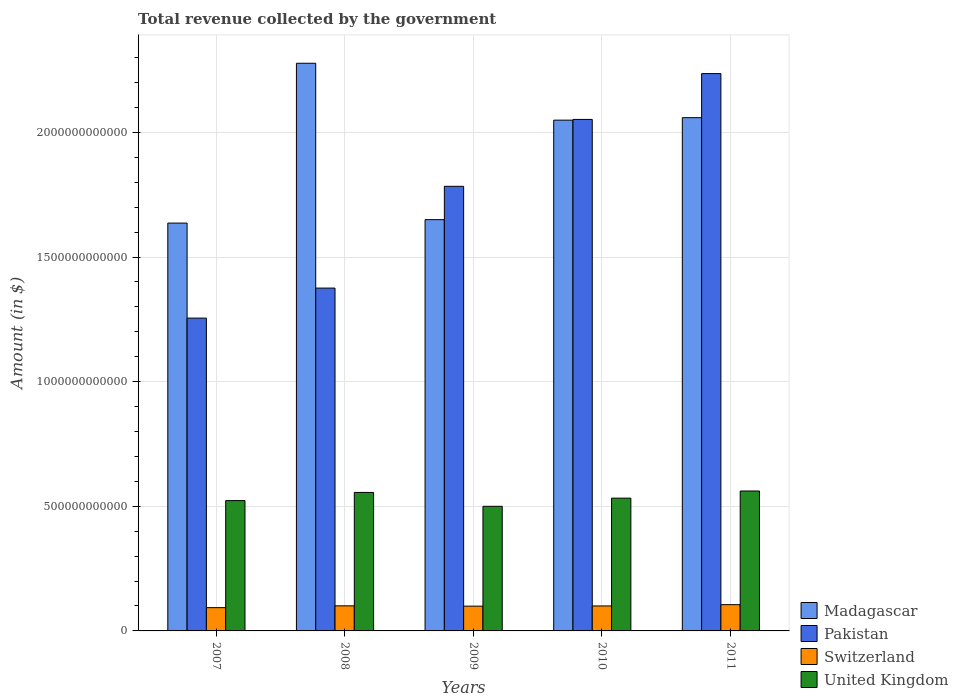How many different coloured bars are there?
Your answer should be compact. 4. Are the number of bars on each tick of the X-axis equal?
Your answer should be very brief. Yes. How many bars are there on the 5th tick from the left?
Provide a succinct answer. 4. What is the total revenue collected by the government in Switzerland in 2009?
Your answer should be very brief. 9.94e+1. Across all years, what is the maximum total revenue collected by the government in United Kingdom?
Your answer should be very brief. 5.61e+11. Across all years, what is the minimum total revenue collected by the government in Madagascar?
Keep it short and to the point. 1.64e+12. In which year was the total revenue collected by the government in Switzerland minimum?
Offer a terse response. 2007. What is the total total revenue collected by the government in Switzerland in the graph?
Keep it short and to the point. 4.99e+11. What is the difference between the total revenue collected by the government in Pakistan in 2007 and that in 2009?
Make the answer very short. -5.29e+11. What is the difference between the total revenue collected by the government in Madagascar in 2010 and the total revenue collected by the government in Pakistan in 2009?
Make the answer very short. 2.65e+11. What is the average total revenue collected by the government in Pakistan per year?
Your answer should be very brief. 1.74e+12. In the year 2007, what is the difference between the total revenue collected by the government in United Kingdom and total revenue collected by the government in Switzerland?
Provide a short and direct response. 4.29e+11. In how many years, is the total revenue collected by the government in Pakistan greater than 700000000000 $?
Your answer should be very brief. 5. What is the ratio of the total revenue collected by the government in Switzerland in 2007 to that in 2008?
Offer a very short reply. 0.93. Is the total revenue collected by the government in Madagascar in 2008 less than that in 2011?
Provide a short and direct response. No. Is the difference between the total revenue collected by the government in United Kingdom in 2007 and 2008 greater than the difference between the total revenue collected by the government in Switzerland in 2007 and 2008?
Offer a very short reply. No. What is the difference between the highest and the second highest total revenue collected by the government in Switzerland?
Provide a short and direct response. 4.70e+09. What is the difference between the highest and the lowest total revenue collected by the government in Pakistan?
Provide a succinct answer. 9.81e+11. Is the sum of the total revenue collected by the government in Pakistan in 2008 and 2009 greater than the maximum total revenue collected by the government in Madagascar across all years?
Offer a terse response. Yes. Is it the case that in every year, the sum of the total revenue collected by the government in Pakistan and total revenue collected by the government in Switzerland is greater than the sum of total revenue collected by the government in United Kingdom and total revenue collected by the government in Madagascar?
Your answer should be very brief. Yes. What does the 3rd bar from the left in 2011 represents?
Offer a very short reply. Switzerland. What does the 2nd bar from the right in 2011 represents?
Your response must be concise. Switzerland. How many bars are there?
Give a very brief answer. 20. Are all the bars in the graph horizontal?
Make the answer very short. No. What is the difference between two consecutive major ticks on the Y-axis?
Keep it short and to the point. 5.00e+11. Does the graph contain any zero values?
Offer a very short reply. No. Does the graph contain grids?
Your answer should be compact. Yes. Where does the legend appear in the graph?
Provide a succinct answer. Bottom right. How many legend labels are there?
Keep it short and to the point. 4. What is the title of the graph?
Your response must be concise. Total revenue collected by the government. What is the label or title of the X-axis?
Provide a succinct answer. Years. What is the label or title of the Y-axis?
Your answer should be very brief. Amount (in $). What is the Amount (in $) in Madagascar in 2007?
Your answer should be very brief. 1.64e+12. What is the Amount (in $) in Pakistan in 2007?
Your answer should be very brief. 1.25e+12. What is the Amount (in $) in Switzerland in 2007?
Your answer should be very brief. 9.34e+1. What is the Amount (in $) of United Kingdom in 2007?
Offer a very short reply. 5.23e+11. What is the Amount (in $) of Madagascar in 2008?
Ensure brevity in your answer.  2.28e+12. What is the Amount (in $) of Pakistan in 2008?
Your response must be concise. 1.38e+12. What is the Amount (in $) of Switzerland in 2008?
Offer a very short reply. 1.01e+11. What is the Amount (in $) in United Kingdom in 2008?
Your answer should be compact. 5.56e+11. What is the Amount (in $) of Madagascar in 2009?
Your answer should be very brief. 1.65e+12. What is the Amount (in $) of Pakistan in 2009?
Offer a very short reply. 1.78e+12. What is the Amount (in $) in Switzerland in 2009?
Offer a very short reply. 9.94e+1. What is the Amount (in $) of United Kingdom in 2009?
Offer a very short reply. 5.00e+11. What is the Amount (in $) of Madagascar in 2010?
Provide a short and direct response. 2.05e+12. What is the Amount (in $) of Pakistan in 2010?
Ensure brevity in your answer.  2.05e+12. What is the Amount (in $) in Switzerland in 2010?
Your answer should be very brief. 1.00e+11. What is the Amount (in $) in United Kingdom in 2010?
Your answer should be compact. 5.33e+11. What is the Amount (in $) in Madagascar in 2011?
Offer a very short reply. 2.06e+12. What is the Amount (in $) of Pakistan in 2011?
Make the answer very short. 2.24e+12. What is the Amount (in $) of Switzerland in 2011?
Give a very brief answer. 1.05e+11. What is the Amount (in $) of United Kingdom in 2011?
Provide a succinct answer. 5.61e+11. Across all years, what is the maximum Amount (in $) in Madagascar?
Offer a terse response. 2.28e+12. Across all years, what is the maximum Amount (in $) in Pakistan?
Provide a succinct answer. 2.24e+12. Across all years, what is the maximum Amount (in $) of Switzerland?
Offer a terse response. 1.05e+11. Across all years, what is the maximum Amount (in $) in United Kingdom?
Offer a very short reply. 5.61e+11. Across all years, what is the minimum Amount (in $) in Madagascar?
Provide a short and direct response. 1.64e+12. Across all years, what is the minimum Amount (in $) in Pakistan?
Provide a short and direct response. 1.25e+12. Across all years, what is the minimum Amount (in $) of Switzerland?
Your answer should be compact. 9.34e+1. Across all years, what is the minimum Amount (in $) in United Kingdom?
Your response must be concise. 5.00e+11. What is the total Amount (in $) of Madagascar in the graph?
Ensure brevity in your answer.  9.67e+12. What is the total Amount (in $) of Pakistan in the graph?
Ensure brevity in your answer.  8.70e+12. What is the total Amount (in $) in Switzerland in the graph?
Offer a terse response. 4.99e+11. What is the total Amount (in $) in United Kingdom in the graph?
Provide a succinct answer. 2.67e+12. What is the difference between the Amount (in $) of Madagascar in 2007 and that in 2008?
Your answer should be very brief. -6.41e+11. What is the difference between the Amount (in $) of Pakistan in 2007 and that in 2008?
Offer a terse response. -1.20e+11. What is the difference between the Amount (in $) of Switzerland in 2007 and that in 2008?
Give a very brief answer. -7.27e+09. What is the difference between the Amount (in $) in United Kingdom in 2007 and that in 2008?
Make the answer very short. -3.27e+1. What is the difference between the Amount (in $) of Madagascar in 2007 and that in 2009?
Your answer should be compact. -1.38e+1. What is the difference between the Amount (in $) in Pakistan in 2007 and that in 2009?
Provide a short and direct response. -5.29e+11. What is the difference between the Amount (in $) of Switzerland in 2007 and that in 2009?
Ensure brevity in your answer.  -6.03e+09. What is the difference between the Amount (in $) in United Kingdom in 2007 and that in 2009?
Keep it short and to the point. 2.29e+1. What is the difference between the Amount (in $) in Madagascar in 2007 and that in 2010?
Give a very brief answer. -4.13e+11. What is the difference between the Amount (in $) in Pakistan in 2007 and that in 2010?
Your answer should be very brief. -7.97e+11. What is the difference between the Amount (in $) of Switzerland in 2007 and that in 2010?
Provide a short and direct response. -6.83e+09. What is the difference between the Amount (in $) in United Kingdom in 2007 and that in 2010?
Offer a terse response. -9.82e+09. What is the difference between the Amount (in $) in Madagascar in 2007 and that in 2011?
Ensure brevity in your answer.  -4.23e+11. What is the difference between the Amount (in $) of Pakistan in 2007 and that in 2011?
Provide a succinct answer. -9.81e+11. What is the difference between the Amount (in $) of Switzerland in 2007 and that in 2011?
Your response must be concise. -1.20e+1. What is the difference between the Amount (in $) in United Kingdom in 2007 and that in 2011?
Your answer should be very brief. -3.85e+1. What is the difference between the Amount (in $) of Madagascar in 2008 and that in 2009?
Offer a very short reply. 6.27e+11. What is the difference between the Amount (in $) of Pakistan in 2008 and that in 2009?
Make the answer very short. -4.08e+11. What is the difference between the Amount (in $) in Switzerland in 2008 and that in 2009?
Provide a short and direct response. 1.24e+09. What is the difference between the Amount (in $) of United Kingdom in 2008 and that in 2009?
Your response must be concise. 5.56e+1. What is the difference between the Amount (in $) in Madagascar in 2008 and that in 2010?
Give a very brief answer. 2.28e+11. What is the difference between the Amount (in $) in Pakistan in 2008 and that in 2010?
Ensure brevity in your answer.  -6.77e+11. What is the difference between the Amount (in $) in Switzerland in 2008 and that in 2010?
Give a very brief answer. 4.42e+08. What is the difference between the Amount (in $) in United Kingdom in 2008 and that in 2010?
Your answer should be compact. 2.29e+1. What is the difference between the Amount (in $) in Madagascar in 2008 and that in 2011?
Offer a terse response. 2.18e+11. What is the difference between the Amount (in $) in Pakistan in 2008 and that in 2011?
Provide a short and direct response. -8.61e+11. What is the difference between the Amount (in $) of Switzerland in 2008 and that in 2011?
Your answer should be compact. -4.70e+09. What is the difference between the Amount (in $) in United Kingdom in 2008 and that in 2011?
Offer a very short reply. -5.77e+09. What is the difference between the Amount (in $) in Madagascar in 2009 and that in 2010?
Your answer should be very brief. -3.99e+11. What is the difference between the Amount (in $) in Pakistan in 2009 and that in 2010?
Offer a very short reply. -2.68e+11. What is the difference between the Amount (in $) of Switzerland in 2009 and that in 2010?
Ensure brevity in your answer.  -7.94e+08. What is the difference between the Amount (in $) in United Kingdom in 2009 and that in 2010?
Your answer should be compact. -3.27e+1. What is the difference between the Amount (in $) in Madagascar in 2009 and that in 2011?
Your response must be concise. -4.09e+11. What is the difference between the Amount (in $) of Pakistan in 2009 and that in 2011?
Give a very brief answer. -4.52e+11. What is the difference between the Amount (in $) of Switzerland in 2009 and that in 2011?
Ensure brevity in your answer.  -5.94e+09. What is the difference between the Amount (in $) of United Kingdom in 2009 and that in 2011?
Offer a very short reply. -6.14e+1. What is the difference between the Amount (in $) in Madagascar in 2010 and that in 2011?
Your response must be concise. -9.95e+09. What is the difference between the Amount (in $) of Pakistan in 2010 and that in 2011?
Give a very brief answer. -1.84e+11. What is the difference between the Amount (in $) of Switzerland in 2010 and that in 2011?
Provide a short and direct response. -5.14e+09. What is the difference between the Amount (in $) in United Kingdom in 2010 and that in 2011?
Provide a succinct answer. -2.87e+1. What is the difference between the Amount (in $) in Madagascar in 2007 and the Amount (in $) in Pakistan in 2008?
Keep it short and to the point. 2.61e+11. What is the difference between the Amount (in $) of Madagascar in 2007 and the Amount (in $) of Switzerland in 2008?
Provide a succinct answer. 1.54e+12. What is the difference between the Amount (in $) of Madagascar in 2007 and the Amount (in $) of United Kingdom in 2008?
Provide a succinct answer. 1.08e+12. What is the difference between the Amount (in $) of Pakistan in 2007 and the Amount (in $) of Switzerland in 2008?
Give a very brief answer. 1.15e+12. What is the difference between the Amount (in $) in Pakistan in 2007 and the Amount (in $) in United Kingdom in 2008?
Offer a terse response. 6.99e+11. What is the difference between the Amount (in $) of Switzerland in 2007 and the Amount (in $) of United Kingdom in 2008?
Provide a short and direct response. -4.62e+11. What is the difference between the Amount (in $) in Madagascar in 2007 and the Amount (in $) in Pakistan in 2009?
Provide a short and direct response. -1.48e+11. What is the difference between the Amount (in $) in Madagascar in 2007 and the Amount (in $) in Switzerland in 2009?
Your answer should be compact. 1.54e+12. What is the difference between the Amount (in $) of Madagascar in 2007 and the Amount (in $) of United Kingdom in 2009?
Give a very brief answer. 1.14e+12. What is the difference between the Amount (in $) of Pakistan in 2007 and the Amount (in $) of Switzerland in 2009?
Offer a very short reply. 1.16e+12. What is the difference between the Amount (in $) of Pakistan in 2007 and the Amount (in $) of United Kingdom in 2009?
Offer a terse response. 7.55e+11. What is the difference between the Amount (in $) in Switzerland in 2007 and the Amount (in $) in United Kingdom in 2009?
Offer a terse response. -4.07e+11. What is the difference between the Amount (in $) in Madagascar in 2007 and the Amount (in $) in Pakistan in 2010?
Provide a short and direct response. -4.16e+11. What is the difference between the Amount (in $) of Madagascar in 2007 and the Amount (in $) of Switzerland in 2010?
Your response must be concise. 1.54e+12. What is the difference between the Amount (in $) of Madagascar in 2007 and the Amount (in $) of United Kingdom in 2010?
Ensure brevity in your answer.  1.10e+12. What is the difference between the Amount (in $) in Pakistan in 2007 and the Amount (in $) in Switzerland in 2010?
Keep it short and to the point. 1.15e+12. What is the difference between the Amount (in $) of Pakistan in 2007 and the Amount (in $) of United Kingdom in 2010?
Give a very brief answer. 7.22e+11. What is the difference between the Amount (in $) in Switzerland in 2007 and the Amount (in $) in United Kingdom in 2010?
Your response must be concise. -4.39e+11. What is the difference between the Amount (in $) of Madagascar in 2007 and the Amount (in $) of Pakistan in 2011?
Provide a succinct answer. -6.00e+11. What is the difference between the Amount (in $) in Madagascar in 2007 and the Amount (in $) in Switzerland in 2011?
Your answer should be compact. 1.53e+12. What is the difference between the Amount (in $) of Madagascar in 2007 and the Amount (in $) of United Kingdom in 2011?
Keep it short and to the point. 1.07e+12. What is the difference between the Amount (in $) in Pakistan in 2007 and the Amount (in $) in Switzerland in 2011?
Give a very brief answer. 1.15e+12. What is the difference between the Amount (in $) in Pakistan in 2007 and the Amount (in $) in United Kingdom in 2011?
Offer a terse response. 6.94e+11. What is the difference between the Amount (in $) of Switzerland in 2007 and the Amount (in $) of United Kingdom in 2011?
Ensure brevity in your answer.  -4.68e+11. What is the difference between the Amount (in $) of Madagascar in 2008 and the Amount (in $) of Pakistan in 2009?
Ensure brevity in your answer.  4.94e+11. What is the difference between the Amount (in $) of Madagascar in 2008 and the Amount (in $) of Switzerland in 2009?
Make the answer very short. 2.18e+12. What is the difference between the Amount (in $) in Madagascar in 2008 and the Amount (in $) in United Kingdom in 2009?
Your response must be concise. 1.78e+12. What is the difference between the Amount (in $) of Pakistan in 2008 and the Amount (in $) of Switzerland in 2009?
Your answer should be very brief. 1.28e+12. What is the difference between the Amount (in $) of Pakistan in 2008 and the Amount (in $) of United Kingdom in 2009?
Your answer should be very brief. 8.75e+11. What is the difference between the Amount (in $) of Switzerland in 2008 and the Amount (in $) of United Kingdom in 2009?
Offer a very short reply. -3.99e+11. What is the difference between the Amount (in $) in Madagascar in 2008 and the Amount (in $) in Pakistan in 2010?
Offer a very short reply. 2.25e+11. What is the difference between the Amount (in $) in Madagascar in 2008 and the Amount (in $) in Switzerland in 2010?
Provide a succinct answer. 2.18e+12. What is the difference between the Amount (in $) in Madagascar in 2008 and the Amount (in $) in United Kingdom in 2010?
Give a very brief answer. 1.74e+12. What is the difference between the Amount (in $) of Pakistan in 2008 and the Amount (in $) of Switzerland in 2010?
Offer a terse response. 1.28e+12. What is the difference between the Amount (in $) in Pakistan in 2008 and the Amount (in $) in United Kingdom in 2010?
Provide a short and direct response. 8.43e+11. What is the difference between the Amount (in $) in Switzerland in 2008 and the Amount (in $) in United Kingdom in 2010?
Provide a succinct answer. -4.32e+11. What is the difference between the Amount (in $) in Madagascar in 2008 and the Amount (in $) in Pakistan in 2011?
Your response must be concise. 4.14e+1. What is the difference between the Amount (in $) of Madagascar in 2008 and the Amount (in $) of Switzerland in 2011?
Offer a terse response. 2.17e+12. What is the difference between the Amount (in $) of Madagascar in 2008 and the Amount (in $) of United Kingdom in 2011?
Make the answer very short. 1.72e+12. What is the difference between the Amount (in $) of Pakistan in 2008 and the Amount (in $) of Switzerland in 2011?
Your answer should be very brief. 1.27e+12. What is the difference between the Amount (in $) in Pakistan in 2008 and the Amount (in $) in United Kingdom in 2011?
Ensure brevity in your answer.  8.14e+11. What is the difference between the Amount (in $) in Switzerland in 2008 and the Amount (in $) in United Kingdom in 2011?
Offer a very short reply. -4.61e+11. What is the difference between the Amount (in $) in Madagascar in 2009 and the Amount (in $) in Pakistan in 2010?
Keep it short and to the point. -4.02e+11. What is the difference between the Amount (in $) in Madagascar in 2009 and the Amount (in $) in Switzerland in 2010?
Provide a succinct answer. 1.55e+12. What is the difference between the Amount (in $) of Madagascar in 2009 and the Amount (in $) of United Kingdom in 2010?
Provide a short and direct response. 1.12e+12. What is the difference between the Amount (in $) of Pakistan in 2009 and the Amount (in $) of Switzerland in 2010?
Your response must be concise. 1.68e+12. What is the difference between the Amount (in $) in Pakistan in 2009 and the Amount (in $) in United Kingdom in 2010?
Provide a succinct answer. 1.25e+12. What is the difference between the Amount (in $) in Switzerland in 2009 and the Amount (in $) in United Kingdom in 2010?
Give a very brief answer. -4.33e+11. What is the difference between the Amount (in $) in Madagascar in 2009 and the Amount (in $) in Pakistan in 2011?
Provide a succinct answer. -5.86e+11. What is the difference between the Amount (in $) in Madagascar in 2009 and the Amount (in $) in Switzerland in 2011?
Ensure brevity in your answer.  1.54e+12. What is the difference between the Amount (in $) in Madagascar in 2009 and the Amount (in $) in United Kingdom in 2011?
Make the answer very short. 1.09e+12. What is the difference between the Amount (in $) in Pakistan in 2009 and the Amount (in $) in Switzerland in 2011?
Keep it short and to the point. 1.68e+12. What is the difference between the Amount (in $) in Pakistan in 2009 and the Amount (in $) in United Kingdom in 2011?
Keep it short and to the point. 1.22e+12. What is the difference between the Amount (in $) of Switzerland in 2009 and the Amount (in $) of United Kingdom in 2011?
Offer a terse response. -4.62e+11. What is the difference between the Amount (in $) of Madagascar in 2010 and the Amount (in $) of Pakistan in 2011?
Keep it short and to the point. -1.87e+11. What is the difference between the Amount (in $) of Madagascar in 2010 and the Amount (in $) of Switzerland in 2011?
Provide a succinct answer. 1.94e+12. What is the difference between the Amount (in $) of Madagascar in 2010 and the Amount (in $) of United Kingdom in 2011?
Your answer should be very brief. 1.49e+12. What is the difference between the Amount (in $) of Pakistan in 2010 and the Amount (in $) of Switzerland in 2011?
Provide a short and direct response. 1.95e+12. What is the difference between the Amount (in $) of Pakistan in 2010 and the Amount (in $) of United Kingdom in 2011?
Ensure brevity in your answer.  1.49e+12. What is the difference between the Amount (in $) in Switzerland in 2010 and the Amount (in $) in United Kingdom in 2011?
Provide a succinct answer. -4.61e+11. What is the average Amount (in $) of Madagascar per year?
Give a very brief answer. 1.93e+12. What is the average Amount (in $) in Pakistan per year?
Your answer should be very brief. 1.74e+12. What is the average Amount (in $) in Switzerland per year?
Ensure brevity in your answer.  9.98e+1. What is the average Amount (in $) of United Kingdom per year?
Provide a short and direct response. 5.34e+11. In the year 2007, what is the difference between the Amount (in $) in Madagascar and Amount (in $) in Pakistan?
Offer a very short reply. 3.81e+11. In the year 2007, what is the difference between the Amount (in $) in Madagascar and Amount (in $) in Switzerland?
Keep it short and to the point. 1.54e+12. In the year 2007, what is the difference between the Amount (in $) in Madagascar and Amount (in $) in United Kingdom?
Offer a terse response. 1.11e+12. In the year 2007, what is the difference between the Amount (in $) of Pakistan and Amount (in $) of Switzerland?
Offer a very short reply. 1.16e+12. In the year 2007, what is the difference between the Amount (in $) in Pakistan and Amount (in $) in United Kingdom?
Provide a short and direct response. 7.32e+11. In the year 2007, what is the difference between the Amount (in $) of Switzerland and Amount (in $) of United Kingdom?
Provide a succinct answer. -4.29e+11. In the year 2008, what is the difference between the Amount (in $) of Madagascar and Amount (in $) of Pakistan?
Offer a terse response. 9.02e+11. In the year 2008, what is the difference between the Amount (in $) of Madagascar and Amount (in $) of Switzerland?
Your answer should be compact. 2.18e+12. In the year 2008, what is the difference between the Amount (in $) in Madagascar and Amount (in $) in United Kingdom?
Provide a succinct answer. 1.72e+12. In the year 2008, what is the difference between the Amount (in $) of Pakistan and Amount (in $) of Switzerland?
Provide a succinct answer. 1.27e+12. In the year 2008, what is the difference between the Amount (in $) of Pakistan and Amount (in $) of United Kingdom?
Your answer should be very brief. 8.20e+11. In the year 2008, what is the difference between the Amount (in $) in Switzerland and Amount (in $) in United Kingdom?
Provide a succinct answer. -4.55e+11. In the year 2009, what is the difference between the Amount (in $) of Madagascar and Amount (in $) of Pakistan?
Provide a short and direct response. -1.34e+11. In the year 2009, what is the difference between the Amount (in $) in Madagascar and Amount (in $) in Switzerland?
Your response must be concise. 1.55e+12. In the year 2009, what is the difference between the Amount (in $) in Madagascar and Amount (in $) in United Kingdom?
Offer a very short reply. 1.15e+12. In the year 2009, what is the difference between the Amount (in $) in Pakistan and Amount (in $) in Switzerland?
Keep it short and to the point. 1.68e+12. In the year 2009, what is the difference between the Amount (in $) in Pakistan and Amount (in $) in United Kingdom?
Your response must be concise. 1.28e+12. In the year 2009, what is the difference between the Amount (in $) in Switzerland and Amount (in $) in United Kingdom?
Make the answer very short. -4.01e+11. In the year 2010, what is the difference between the Amount (in $) of Madagascar and Amount (in $) of Pakistan?
Give a very brief answer. -2.88e+09. In the year 2010, what is the difference between the Amount (in $) in Madagascar and Amount (in $) in Switzerland?
Keep it short and to the point. 1.95e+12. In the year 2010, what is the difference between the Amount (in $) in Madagascar and Amount (in $) in United Kingdom?
Ensure brevity in your answer.  1.52e+12. In the year 2010, what is the difference between the Amount (in $) in Pakistan and Amount (in $) in Switzerland?
Make the answer very short. 1.95e+12. In the year 2010, what is the difference between the Amount (in $) of Pakistan and Amount (in $) of United Kingdom?
Keep it short and to the point. 1.52e+12. In the year 2010, what is the difference between the Amount (in $) of Switzerland and Amount (in $) of United Kingdom?
Offer a terse response. -4.32e+11. In the year 2011, what is the difference between the Amount (in $) in Madagascar and Amount (in $) in Pakistan?
Provide a succinct answer. -1.77e+11. In the year 2011, what is the difference between the Amount (in $) in Madagascar and Amount (in $) in Switzerland?
Your answer should be compact. 1.95e+12. In the year 2011, what is the difference between the Amount (in $) in Madagascar and Amount (in $) in United Kingdom?
Keep it short and to the point. 1.50e+12. In the year 2011, what is the difference between the Amount (in $) of Pakistan and Amount (in $) of Switzerland?
Offer a terse response. 2.13e+12. In the year 2011, what is the difference between the Amount (in $) of Pakistan and Amount (in $) of United Kingdom?
Ensure brevity in your answer.  1.67e+12. In the year 2011, what is the difference between the Amount (in $) in Switzerland and Amount (in $) in United Kingdom?
Provide a short and direct response. -4.56e+11. What is the ratio of the Amount (in $) of Madagascar in 2007 to that in 2008?
Provide a short and direct response. 0.72. What is the ratio of the Amount (in $) of Pakistan in 2007 to that in 2008?
Your answer should be compact. 0.91. What is the ratio of the Amount (in $) of Switzerland in 2007 to that in 2008?
Provide a succinct answer. 0.93. What is the ratio of the Amount (in $) in United Kingdom in 2007 to that in 2008?
Make the answer very short. 0.94. What is the ratio of the Amount (in $) in Pakistan in 2007 to that in 2009?
Your answer should be very brief. 0.7. What is the ratio of the Amount (in $) of Switzerland in 2007 to that in 2009?
Ensure brevity in your answer.  0.94. What is the ratio of the Amount (in $) of United Kingdom in 2007 to that in 2009?
Offer a terse response. 1.05. What is the ratio of the Amount (in $) in Madagascar in 2007 to that in 2010?
Keep it short and to the point. 0.8. What is the ratio of the Amount (in $) of Pakistan in 2007 to that in 2010?
Give a very brief answer. 0.61. What is the ratio of the Amount (in $) of Switzerland in 2007 to that in 2010?
Provide a short and direct response. 0.93. What is the ratio of the Amount (in $) in United Kingdom in 2007 to that in 2010?
Keep it short and to the point. 0.98. What is the ratio of the Amount (in $) in Madagascar in 2007 to that in 2011?
Offer a terse response. 0.79. What is the ratio of the Amount (in $) of Pakistan in 2007 to that in 2011?
Your response must be concise. 0.56. What is the ratio of the Amount (in $) in Switzerland in 2007 to that in 2011?
Your answer should be very brief. 0.89. What is the ratio of the Amount (in $) of United Kingdom in 2007 to that in 2011?
Keep it short and to the point. 0.93. What is the ratio of the Amount (in $) of Madagascar in 2008 to that in 2009?
Ensure brevity in your answer.  1.38. What is the ratio of the Amount (in $) of Pakistan in 2008 to that in 2009?
Offer a very short reply. 0.77. What is the ratio of the Amount (in $) in Switzerland in 2008 to that in 2009?
Provide a succinct answer. 1.01. What is the ratio of the Amount (in $) of United Kingdom in 2008 to that in 2009?
Keep it short and to the point. 1.11. What is the ratio of the Amount (in $) in Madagascar in 2008 to that in 2010?
Offer a very short reply. 1.11. What is the ratio of the Amount (in $) of Pakistan in 2008 to that in 2010?
Give a very brief answer. 0.67. What is the ratio of the Amount (in $) of United Kingdom in 2008 to that in 2010?
Give a very brief answer. 1.04. What is the ratio of the Amount (in $) in Madagascar in 2008 to that in 2011?
Offer a very short reply. 1.11. What is the ratio of the Amount (in $) of Pakistan in 2008 to that in 2011?
Keep it short and to the point. 0.62. What is the ratio of the Amount (in $) in Switzerland in 2008 to that in 2011?
Your answer should be compact. 0.96. What is the ratio of the Amount (in $) of Madagascar in 2009 to that in 2010?
Offer a very short reply. 0.81. What is the ratio of the Amount (in $) in Pakistan in 2009 to that in 2010?
Your response must be concise. 0.87. What is the ratio of the Amount (in $) in Switzerland in 2009 to that in 2010?
Your response must be concise. 0.99. What is the ratio of the Amount (in $) in United Kingdom in 2009 to that in 2010?
Offer a terse response. 0.94. What is the ratio of the Amount (in $) of Madagascar in 2009 to that in 2011?
Give a very brief answer. 0.8. What is the ratio of the Amount (in $) in Pakistan in 2009 to that in 2011?
Offer a very short reply. 0.8. What is the ratio of the Amount (in $) in Switzerland in 2009 to that in 2011?
Your answer should be very brief. 0.94. What is the ratio of the Amount (in $) in United Kingdom in 2009 to that in 2011?
Keep it short and to the point. 0.89. What is the ratio of the Amount (in $) in Madagascar in 2010 to that in 2011?
Your answer should be very brief. 1. What is the ratio of the Amount (in $) in Pakistan in 2010 to that in 2011?
Make the answer very short. 0.92. What is the ratio of the Amount (in $) in Switzerland in 2010 to that in 2011?
Make the answer very short. 0.95. What is the ratio of the Amount (in $) of United Kingdom in 2010 to that in 2011?
Your response must be concise. 0.95. What is the difference between the highest and the second highest Amount (in $) of Madagascar?
Provide a succinct answer. 2.18e+11. What is the difference between the highest and the second highest Amount (in $) in Pakistan?
Your response must be concise. 1.84e+11. What is the difference between the highest and the second highest Amount (in $) in Switzerland?
Provide a short and direct response. 4.70e+09. What is the difference between the highest and the second highest Amount (in $) of United Kingdom?
Your answer should be compact. 5.77e+09. What is the difference between the highest and the lowest Amount (in $) in Madagascar?
Provide a short and direct response. 6.41e+11. What is the difference between the highest and the lowest Amount (in $) in Pakistan?
Give a very brief answer. 9.81e+11. What is the difference between the highest and the lowest Amount (in $) in Switzerland?
Give a very brief answer. 1.20e+1. What is the difference between the highest and the lowest Amount (in $) in United Kingdom?
Provide a short and direct response. 6.14e+1. 